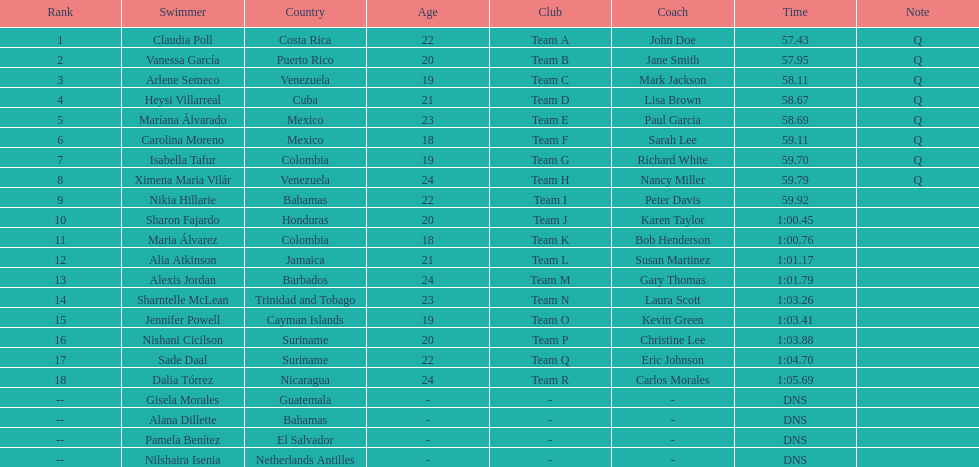How many swimmers had a time of at least 1:00 9. 